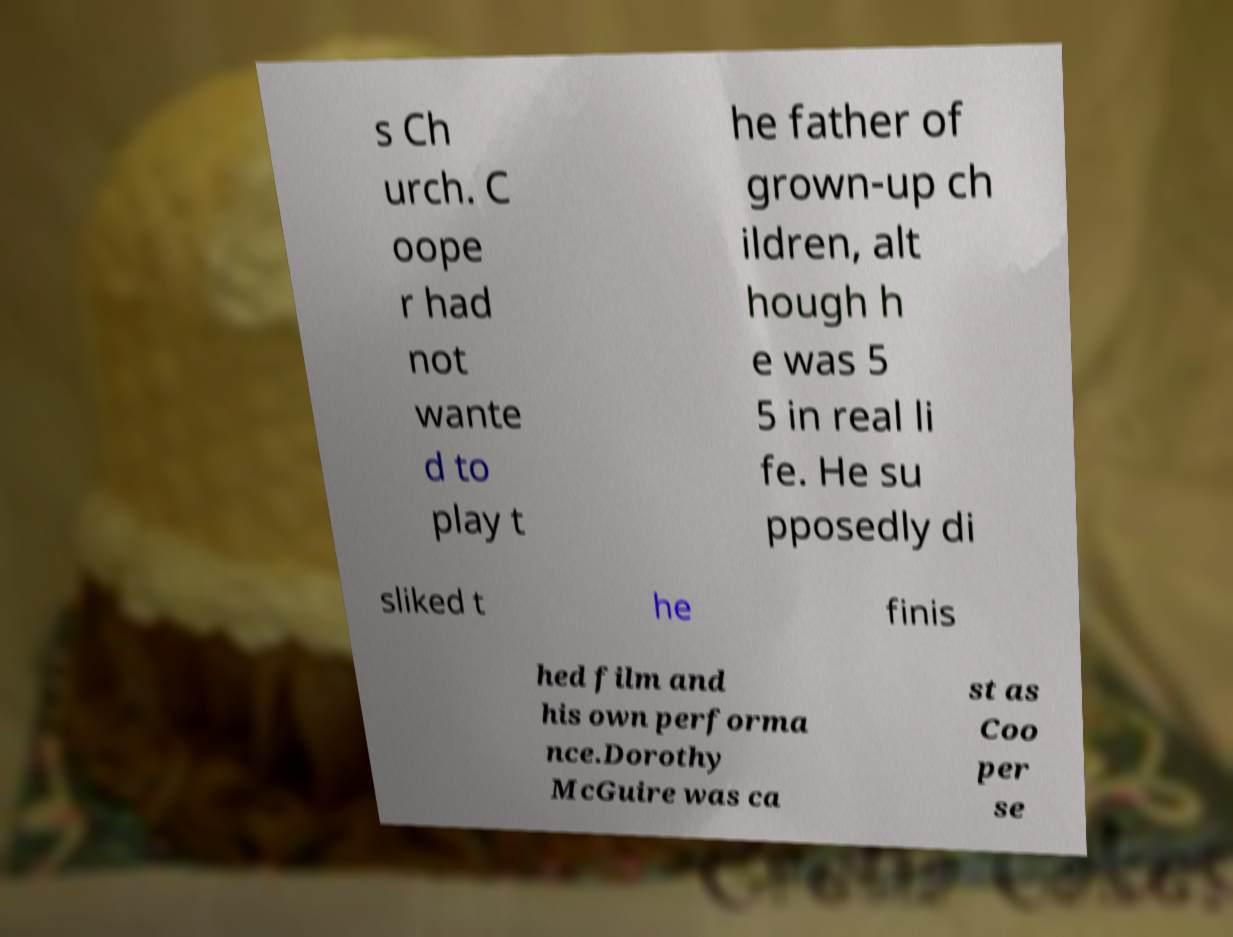Can you accurately transcribe the text from the provided image for me? s Ch urch. C oope r had not wante d to play t he father of grown-up ch ildren, alt hough h e was 5 5 in real li fe. He su pposedly di sliked t he finis hed film and his own performa nce.Dorothy McGuire was ca st as Coo per se 